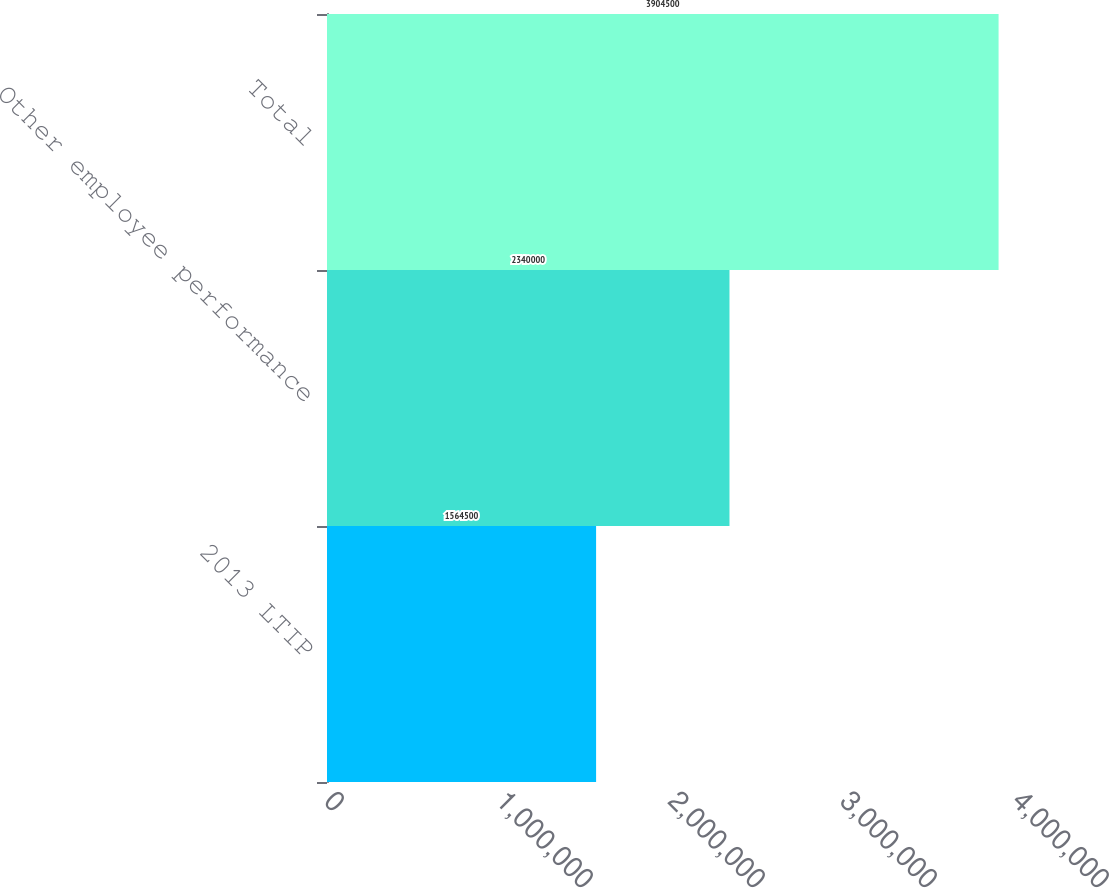Convert chart. <chart><loc_0><loc_0><loc_500><loc_500><bar_chart><fcel>2013 LTIP<fcel>Other employee performance<fcel>Total<nl><fcel>1.5645e+06<fcel>2.34e+06<fcel>3.9045e+06<nl></chart> 